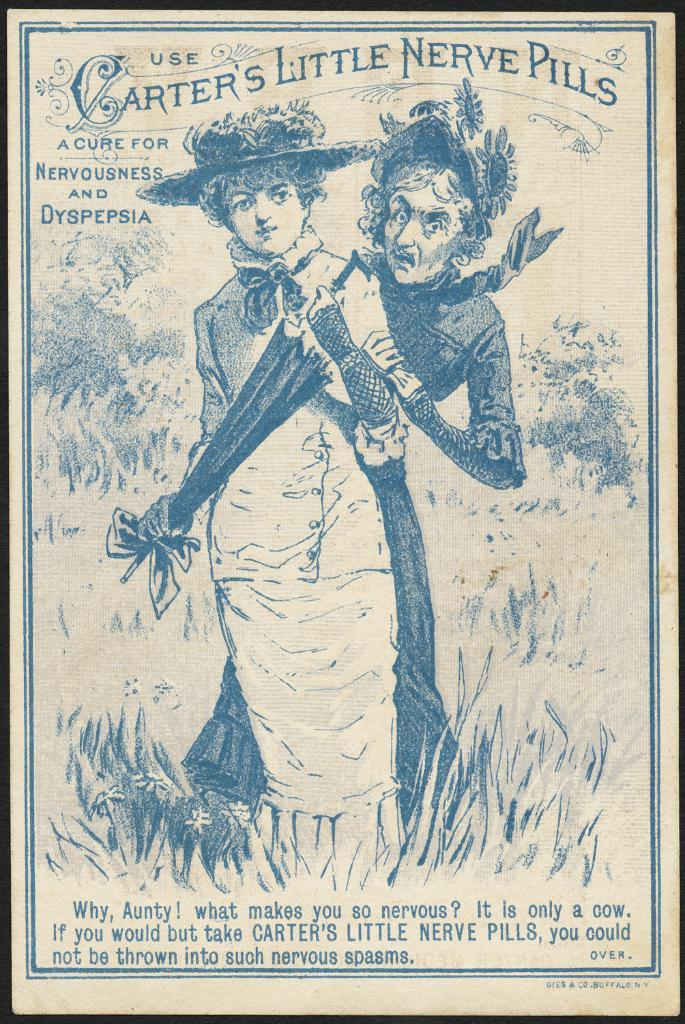What is depicted in the image? There is a picture of two people in the image. Can you describe any additional features of the image? There is text present on the picture. What type of beast can be seen kissing one of the people in the image? There is no beast present in the image, and no one is depicted kissing in the image. 